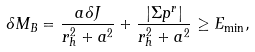<formula> <loc_0><loc_0><loc_500><loc_500>\delta M _ { B } = \frac { a \delta J } { r _ { h } ^ { 2 } + a ^ { 2 } } + \frac { | \Sigma p ^ { r } | } { r _ { h } ^ { 2 } + a ^ { 2 } } \geq E _ { \min } ,</formula> 